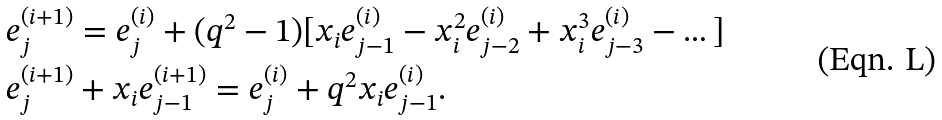<formula> <loc_0><loc_0><loc_500><loc_500>& e _ { j } ^ { ( i + 1 ) } = e _ { j } ^ { ( i ) } + ( q ^ { 2 } - 1 ) [ x _ { i } e _ { j - 1 } ^ { ( i ) } - x _ { i } ^ { 2 } e _ { j - 2 } ^ { ( i ) } + x _ { i } ^ { 3 } e _ { j - 3 } ^ { ( i ) } - \dots ] \\ & e _ { j } ^ { ( i + 1 ) } + x _ { i } e _ { j - 1 } ^ { ( i + 1 ) } = e _ { j } ^ { ( i ) } + q ^ { 2 } x _ { i } e _ { j - 1 } ^ { ( i ) } .</formula> 